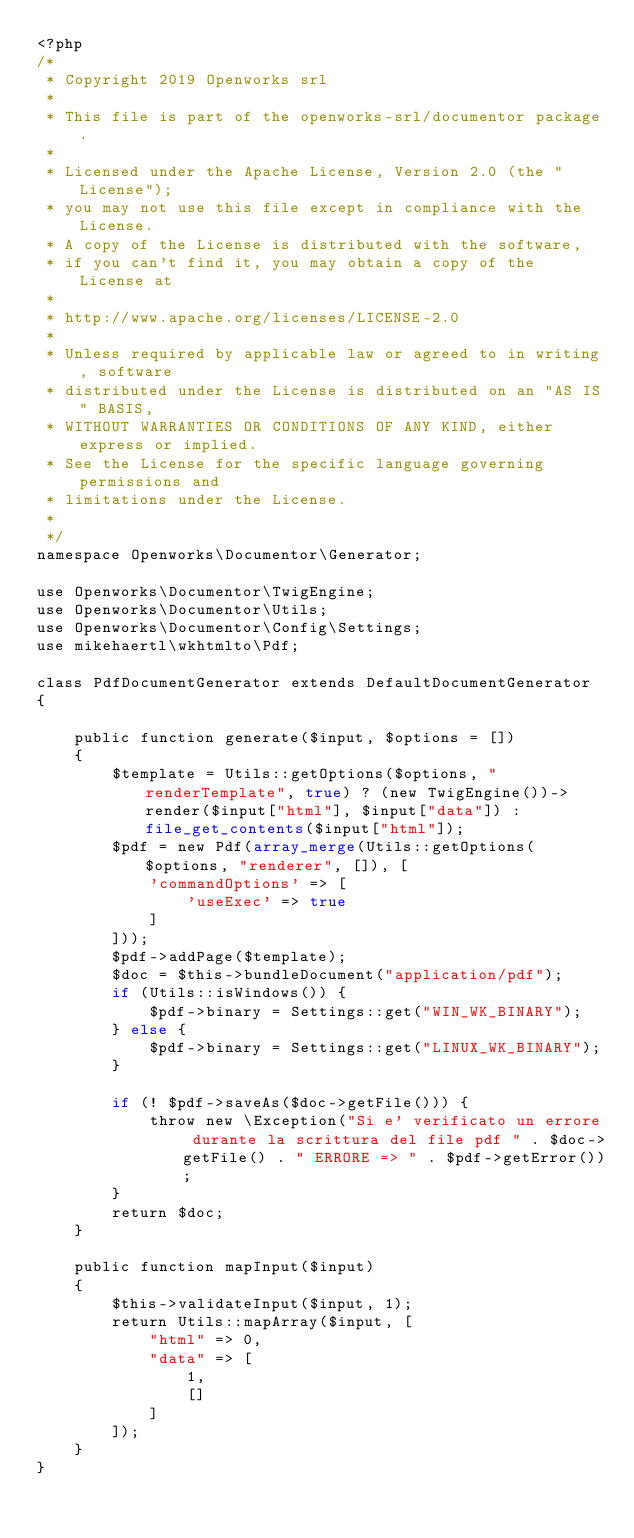Convert code to text. <code><loc_0><loc_0><loc_500><loc_500><_PHP_><?php
/*
 * Copyright 2019 Openworks srl
 *
 * This file is part of the openworks-srl/documentor package.
 *
 * Licensed under the Apache License, Version 2.0 (the "License");
 * you may not use this file except in compliance with the License.
 * A copy of the License is distributed with the software,
 * if you can't find it, you may obtain a copy of the License at
 *
 * http://www.apache.org/licenses/LICENSE-2.0
 *
 * Unless required by applicable law or agreed to in writing, software
 * distributed under the License is distributed on an "AS IS" BASIS,
 * WITHOUT WARRANTIES OR CONDITIONS OF ANY KIND, either express or implied.
 * See the License for the specific language governing permissions and
 * limitations under the License.
 * 
 */
namespace Openworks\Documentor\Generator;

use Openworks\Documentor\TwigEngine;
use Openworks\Documentor\Utils;
use Openworks\Documentor\Config\Settings;
use mikehaertl\wkhtmlto\Pdf;

class PdfDocumentGenerator extends DefaultDocumentGenerator
{

    public function generate($input, $options = [])
    {
        $template = Utils::getOptions($options, "renderTemplate", true) ? (new TwigEngine())->render($input["html"], $input["data"]) : file_get_contents($input["html"]);
        $pdf = new Pdf(array_merge(Utils::getOptions($options, "renderer", []), [
            'commandOptions' => [
                'useExec' => true
            ]
        ]));
        $pdf->addPage($template);
        $doc = $this->bundleDocument("application/pdf");
        if (Utils::isWindows()) {
            $pdf->binary = Settings::get("WIN_WK_BINARY");
        } else {
            $pdf->binary = Settings::get("LINUX_WK_BINARY");
        }

        if (! $pdf->saveAs($doc->getFile())) {
            throw new \Exception("Si e' verificato un errore durante la scrittura del file pdf " . $doc->getFile() . " ERRORE => " . $pdf->getError());
        }
        return $doc;
    }

    public function mapInput($input)
    {
        $this->validateInput($input, 1);
        return Utils::mapArray($input, [
            "html" => 0,
            "data" => [
                1,
                []
            ]
        ]);
    }
}

</code> 